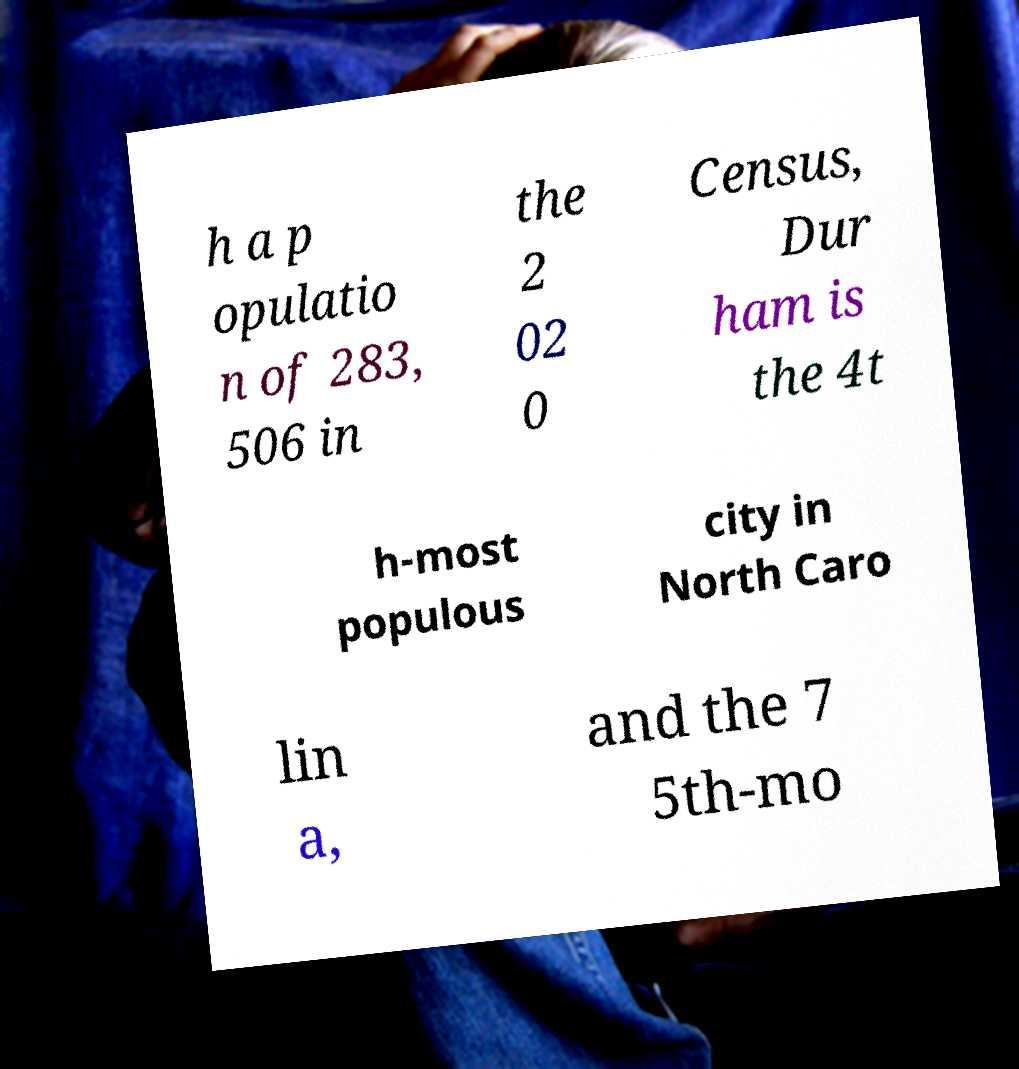I need the written content from this picture converted into text. Can you do that? h a p opulatio n of 283, 506 in the 2 02 0 Census, Dur ham is the 4t h-most populous city in North Caro lin a, and the 7 5th-mo 